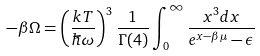<formula> <loc_0><loc_0><loc_500><loc_500>- \beta \Omega = \left ( \frac { k T } { \hbar { \omega } } \right ) ^ { 3 } \frac { 1 } { \Gamma ( 4 ) } \int _ { 0 } ^ { \infty } \frac { x ^ { 3 } d x } { e ^ { x - \beta \mu } - \epsilon }</formula> 